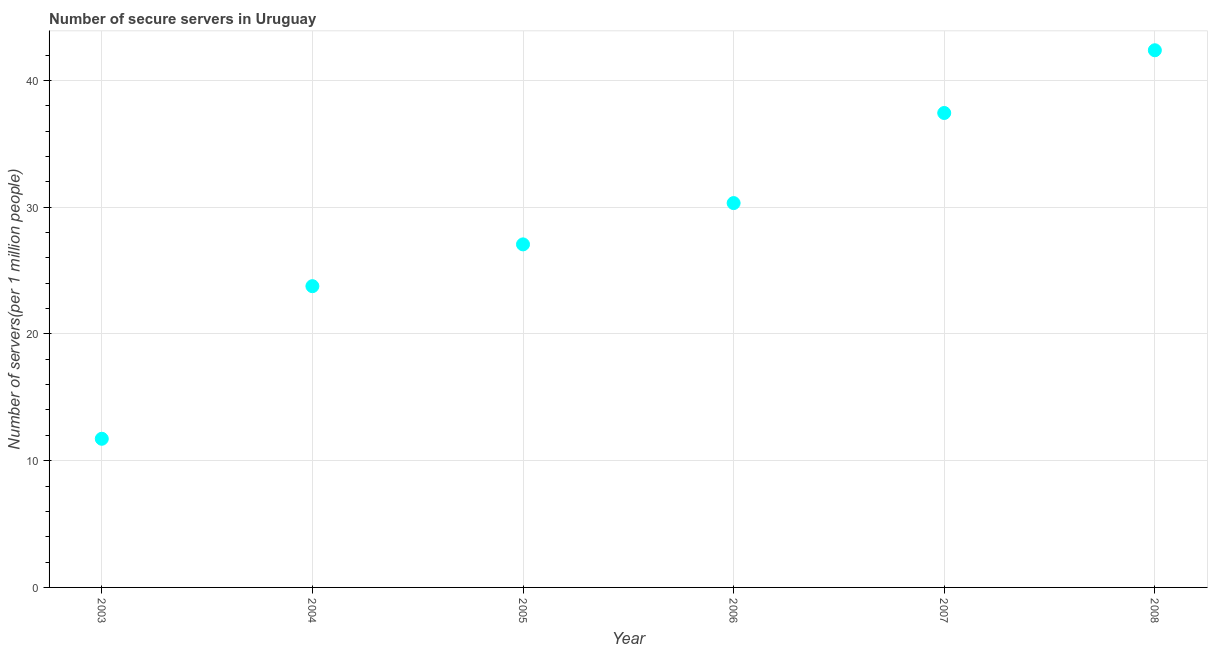What is the number of secure internet servers in 2003?
Offer a terse response. 11.73. Across all years, what is the maximum number of secure internet servers?
Offer a terse response. 42.38. Across all years, what is the minimum number of secure internet servers?
Offer a terse response. 11.73. In which year was the number of secure internet servers minimum?
Make the answer very short. 2003. What is the sum of the number of secure internet servers?
Make the answer very short. 172.68. What is the difference between the number of secure internet servers in 2004 and 2007?
Offer a very short reply. -13.66. What is the average number of secure internet servers per year?
Your response must be concise. 28.78. What is the median number of secure internet servers?
Your answer should be compact. 28.69. In how many years, is the number of secure internet servers greater than 40 ?
Keep it short and to the point. 1. Do a majority of the years between 2006 and 2005 (inclusive) have number of secure internet servers greater than 38 ?
Offer a terse response. No. What is the ratio of the number of secure internet servers in 2003 to that in 2006?
Provide a short and direct response. 0.39. Is the difference between the number of secure internet servers in 2005 and 2006 greater than the difference between any two years?
Your answer should be compact. No. What is the difference between the highest and the second highest number of secure internet servers?
Ensure brevity in your answer.  4.95. Is the sum of the number of secure internet servers in 2005 and 2008 greater than the maximum number of secure internet servers across all years?
Keep it short and to the point. Yes. What is the difference between the highest and the lowest number of secure internet servers?
Your answer should be compact. 30.65. What is the title of the graph?
Your answer should be very brief. Number of secure servers in Uruguay. What is the label or title of the Y-axis?
Your answer should be very brief. Number of servers(per 1 million people). What is the Number of servers(per 1 million people) in 2003?
Offer a terse response. 11.73. What is the Number of servers(per 1 million people) in 2004?
Your answer should be very brief. 23.77. What is the Number of servers(per 1 million people) in 2005?
Ensure brevity in your answer.  27.06. What is the Number of servers(per 1 million people) in 2006?
Keep it short and to the point. 30.32. What is the Number of servers(per 1 million people) in 2007?
Your response must be concise. 37.43. What is the Number of servers(per 1 million people) in 2008?
Ensure brevity in your answer.  42.38. What is the difference between the Number of servers(per 1 million people) in 2003 and 2004?
Keep it short and to the point. -12.04. What is the difference between the Number of servers(per 1 million people) in 2003 and 2005?
Give a very brief answer. -15.34. What is the difference between the Number of servers(per 1 million people) in 2003 and 2006?
Ensure brevity in your answer.  -18.59. What is the difference between the Number of servers(per 1 million people) in 2003 and 2007?
Ensure brevity in your answer.  -25.7. What is the difference between the Number of servers(per 1 million people) in 2003 and 2008?
Provide a succinct answer. -30.65. What is the difference between the Number of servers(per 1 million people) in 2004 and 2005?
Your answer should be very brief. -3.3. What is the difference between the Number of servers(per 1 million people) in 2004 and 2006?
Give a very brief answer. -6.55. What is the difference between the Number of servers(per 1 million people) in 2004 and 2007?
Provide a succinct answer. -13.66. What is the difference between the Number of servers(per 1 million people) in 2004 and 2008?
Offer a very short reply. -18.61. What is the difference between the Number of servers(per 1 million people) in 2005 and 2006?
Offer a very short reply. -3.26. What is the difference between the Number of servers(per 1 million people) in 2005 and 2007?
Make the answer very short. -10.37. What is the difference between the Number of servers(per 1 million people) in 2005 and 2008?
Provide a short and direct response. -15.31. What is the difference between the Number of servers(per 1 million people) in 2006 and 2007?
Provide a succinct answer. -7.11. What is the difference between the Number of servers(per 1 million people) in 2006 and 2008?
Your answer should be very brief. -12.06. What is the difference between the Number of servers(per 1 million people) in 2007 and 2008?
Keep it short and to the point. -4.95. What is the ratio of the Number of servers(per 1 million people) in 2003 to that in 2004?
Give a very brief answer. 0.49. What is the ratio of the Number of servers(per 1 million people) in 2003 to that in 2005?
Provide a short and direct response. 0.43. What is the ratio of the Number of servers(per 1 million people) in 2003 to that in 2006?
Your answer should be compact. 0.39. What is the ratio of the Number of servers(per 1 million people) in 2003 to that in 2007?
Offer a terse response. 0.31. What is the ratio of the Number of servers(per 1 million people) in 2003 to that in 2008?
Keep it short and to the point. 0.28. What is the ratio of the Number of servers(per 1 million people) in 2004 to that in 2005?
Provide a succinct answer. 0.88. What is the ratio of the Number of servers(per 1 million people) in 2004 to that in 2006?
Give a very brief answer. 0.78. What is the ratio of the Number of servers(per 1 million people) in 2004 to that in 2007?
Offer a terse response. 0.64. What is the ratio of the Number of servers(per 1 million people) in 2004 to that in 2008?
Keep it short and to the point. 0.56. What is the ratio of the Number of servers(per 1 million people) in 2005 to that in 2006?
Offer a very short reply. 0.89. What is the ratio of the Number of servers(per 1 million people) in 2005 to that in 2007?
Offer a terse response. 0.72. What is the ratio of the Number of servers(per 1 million people) in 2005 to that in 2008?
Provide a succinct answer. 0.64. What is the ratio of the Number of servers(per 1 million people) in 2006 to that in 2007?
Your answer should be compact. 0.81. What is the ratio of the Number of servers(per 1 million people) in 2006 to that in 2008?
Keep it short and to the point. 0.71. What is the ratio of the Number of servers(per 1 million people) in 2007 to that in 2008?
Offer a very short reply. 0.88. 